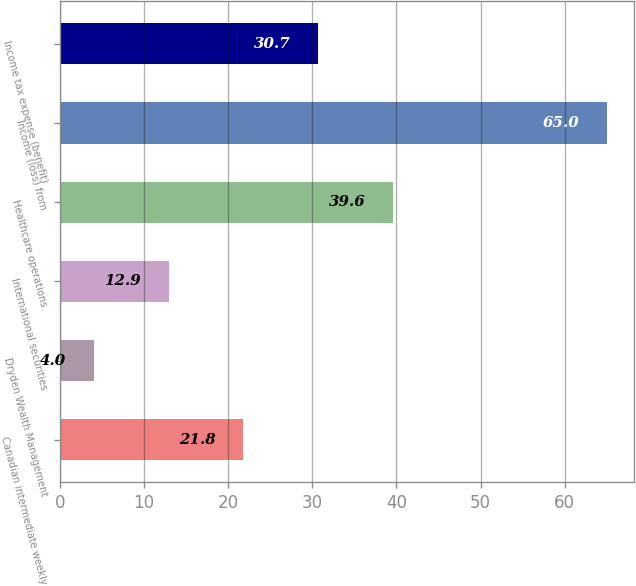Convert chart. <chart><loc_0><loc_0><loc_500><loc_500><bar_chart><fcel>Canadian intermediate weekly<fcel>Dryden Wealth Management<fcel>International securities<fcel>Healthcare operations<fcel>Income (loss) from<fcel>Income tax expense (benefit)<nl><fcel>21.8<fcel>4<fcel>12.9<fcel>39.6<fcel>65<fcel>30.7<nl></chart> 